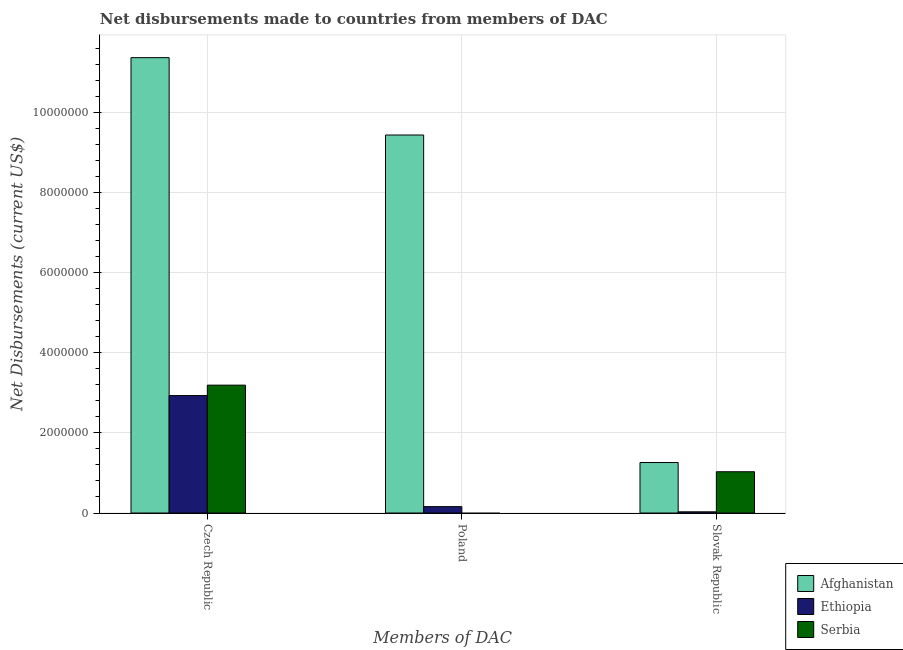How many different coloured bars are there?
Make the answer very short. 3. How many groups of bars are there?
Provide a short and direct response. 3. Are the number of bars on each tick of the X-axis equal?
Your answer should be compact. No. How many bars are there on the 3rd tick from the left?
Your response must be concise. 3. How many bars are there on the 1st tick from the right?
Provide a succinct answer. 3. What is the label of the 1st group of bars from the left?
Provide a short and direct response. Czech Republic. What is the net disbursements made by czech republic in Serbia?
Your answer should be compact. 3.19e+06. Across all countries, what is the maximum net disbursements made by poland?
Ensure brevity in your answer.  9.43e+06. Across all countries, what is the minimum net disbursements made by czech republic?
Ensure brevity in your answer.  2.93e+06. In which country was the net disbursements made by czech republic maximum?
Keep it short and to the point. Afghanistan. What is the total net disbursements made by slovak republic in the graph?
Provide a succinct answer. 2.32e+06. What is the difference between the net disbursements made by czech republic in Ethiopia and that in Afghanistan?
Give a very brief answer. -8.43e+06. What is the difference between the net disbursements made by poland in Ethiopia and the net disbursements made by czech republic in Serbia?
Offer a very short reply. -3.03e+06. What is the average net disbursements made by poland per country?
Give a very brief answer. 3.20e+06. What is the difference between the net disbursements made by poland and net disbursements made by slovak republic in Afghanistan?
Keep it short and to the point. 8.17e+06. What is the ratio of the net disbursements made by czech republic in Ethiopia to that in Afghanistan?
Your answer should be compact. 0.26. Is the difference between the net disbursements made by czech republic in Afghanistan and Ethiopia greater than the difference between the net disbursements made by poland in Afghanistan and Ethiopia?
Provide a short and direct response. No. What is the difference between the highest and the second highest net disbursements made by czech republic?
Your answer should be compact. 8.17e+06. What is the difference between the highest and the lowest net disbursements made by poland?
Your answer should be compact. 9.43e+06. In how many countries, is the net disbursements made by czech republic greater than the average net disbursements made by czech republic taken over all countries?
Your response must be concise. 1. Is it the case that in every country, the sum of the net disbursements made by czech republic and net disbursements made by poland is greater than the net disbursements made by slovak republic?
Give a very brief answer. Yes. Are all the bars in the graph horizontal?
Make the answer very short. No. How many countries are there in the graph?
Keep it short and to the point. 3. What is the difference between two consecutive major ticks on the Y-axis?
Keep it short and to the point. 2.00e+06. Does the graph contain any zero values?
Provide a short and direct response. Yes. Where does the legend appear in the graph?
Give a very brief answer. Bottom right. How many legend labels are there?
Offer a very short reply. 3. How are the legend labels stacked?
Make the answer very short. Vertical. What is the title of the graph?
Keep it short and to the point. Net disbursements made to countries from members of DAC. Does "French Polynesia" appear as one of the legend labels in the graph?
Give a very brief answer. No. What is the label or title of the X-axis?
Your answer should be compact. Members of DAC. What is the label or title of the Y-axis?
Provide a succinct answer. Net Disbursements (current US$). What is the Net Disbursements (current US$) of Afghanistan in Czech Republic?
Offer a terse response. 1.14e+07. What is the Net Disbursements (current US$) of Ethiopia in Czech Republic?
Keep it short and to the point. 2.93e+06. What is the Net Disbursements (current US$) of Serbia in Czech Republic?
Provide a short and direct response. 3.19e+06. What is the Net Disbursements (current US$) of Afghanistan in Poland?
Ensure brevity in your answer.  9.43e+06. What is the Net Disbursements (current US$) in Serbia in Poland?
Your answer should be very brief. 0. What is the Net Disbursements (current US$) in Afghanistan in Slovak Republic?
Your answer should be compact. 1.26e+06. What is the Net Disbursements (current US$) in Serbia in Slovak Republic?
Offer a very short reply. 1.03e+06. Across all Members of DAC, what is the maximum Net Disbursements (current US$) in Afghanistan?
Keep it short and to the point. 1.14e+07. Across all Members of DAC, what is the maximum Net Disbursements (current US$) in Ethiopia?
Provide a succinct answer. 2.93e+06. Across all Members of DAC, what is the maximum Net Disbursements (current US$) of Serbia?
Ensure brevity in your answer.  3.19e+06. Across all Members of DAC, what is the minimum Net Disbursements (current US$) of Afghanistan?
Provide a succinct answer. 1.26e+06. What is the total Net Disbursements (current US$) of Afghanistan in the graph?
Offer a very short reply. 2.20e+07. What is the total Net Disbursements (current US$) of Ethiopia in the graph?
Ensure brevity in your answer.  3.12e+06. What is the total Net Disbursements (current US$) in Serbia in the graph?
Provide a short and direct response. 4.22e+06. What is the difference between the Net Disbursements (current US$) in Afghanistan in Czech Republic and that in Poland?
Provide a short and direct response. 1.93e+06. What is the difference between the Net Disbursements (current US$) in Ethiopia in Czech Republic and that in Poland?
Give a very brief answer. 2.77e+06. What is the difference between the Net Disbursements (current US$) in Afghanistan in Czech Republic and that in Slovak Republic?
Offer a very short reply. 1.01e+07. What is the difference between the Net Disbursements (current US$) in Ethiopia in Czech Republic and that in Slovak Republic?
Your answer should be very brief. 2.90e+06. What is the difference between the Net Disbursements (current US$) in Serbia in Czech Republic and that in Slovak Republic?
Keep it short and to the point. 2.16e+06. What is the difference between the Net Disbursements (current US$) in Afghanistan in Poland and that in Slovak Republic?
Keep it short and to the point. 8.17e+06. What is the difference between the Net Disbursements (current US$) in Ethiopia in Poland and that in Slovak Republic?
Offer a very short reply. 1.30e+05. What is the difference between the Net Disbursements (current US$) in Afghanistan in Czech Republic and the Net Disbursements (current US$) in Ethiopia in Poland?
Give a very brief answer. 1.12e+07. What is the difference between the Net Disbursements (current US$) in Afghanistan in Czech Republic and the Net Disbursements (current US$) in Ethiopia in Slovak Republic?
Provide a succinct answer. 1.13e+07. What is the difference between the Net Disbursements (current US$) of Afghanistan in Czech Republic and the Net Disbursements (current US$) of Serbia in Slovak Republic?
Your answer should be compact. 1.03e+07. What is the difference between the Net Disbursements (current US$) of Ethiopia in Czech Republic and the Net Disbursements (current US$) of Serbia in Slovak Republic?
Give a very brief answer. 1.90e+06. What is the difference between the Net Disbursements (current US$) in Afghanistan in Poland and the Net Disbursements (current US$) in Ethiopia in Slovak Republic?
Your response must be concise. 9.40e+06. What is the difference between the Net Disbursements (current US$) in Afghanistan in Poland and the Net Disbursements (current US$) in Serbia in Slovak Republic?
Give a very brief answer. 8.40e+06. What is the difference between the Net Disbursements (current US$) of Ethiopia in Poland and the Net Disbursements (current US$) of Serbia in Slovak Republic?
Your response must be concise. -8.70e+05. What is the average Net Disbursements (current US$) in Afghanistan per Members of DAC?
Offer a terse response. 7.35e+06. What is the average Net Disbursements (current US$) of Ethiopia per Members of DAC?
Your answer should be compact. 1.04e+06. What is the average Net Disbursements (current US$) in Serbia per Members of DAC?
Provide a succinct answer. 1.41e+06. What is the difference between the Net Disbursements (current US$) of Afghanistan and Net Disbursements (current US$) of Ethiopia in Czech Republic?
Provide a short and direct response. 8.43e+06. What is the difference between the Net Disbursements (current US$) in Afghanistan and Net Disbursements (current US$) in Serbia in Czech Republic?
Your answer should be very brief. 8.17e+06. What is the difference between the Net Disbursements (current US$) of Afghanistan and Net Disbursements (current US$) of Ethiopia in Poland?
Ensure brevity in your answer.  9.27e+06. What is the difference between the Net Disbursements (current US$) of Afghanistan and Net Disbursements (current US$) of Ethiopia in Slovak Republic?
Make the answer very short. 1.23e+06. What is the difference between the Net Disbursements (current US$) in Ethiopia and Net Disbursements (current US$) in Serbia in Slovak Republic?
Your answer should be very brief. -1.00e+06. What is the ratio of the Net Disbursements (current US$) in Afghanistan in Czech Republic to that in Poland?
Offer a very short reply. 1.2. What is the ratio of the Net Disbursements (current US$) in Ethiopia in Czech Republic to that in Poland?
Provide a succinct answer. 18.31. What is the ratio of the Net Disbursements (current US$) in Afghanistan in Czech Republic to that in Slovak Republic?
Provide a short and direct response. 9.02. What is the ratio of the Net Disbursements (current US$) in Ethiopia in Czech Republic to that in Slovak Republic?
Make the answer very short. 97.67. What is the ratio of the Net Disbursements (current US$) of Serbia in Czech Republic to that in Slovak Republic?
Keep it short and to the point. 3.1. What is the ratio of the Net Disbursements (current US$) in Afghanistan in Poland to that in Slovak Republic?
Keep it short and to the point. 7.48. What is the ratio of the Net Disbursements (current US$) of Ethiopia in Poland to that in Slovak Republic?
Your answer should be compact. 5.33. What is the difference between the highest and the second highest Net Disbursements (current US$) in Afghanistan?
Your answer should be very brief. 1.93e+06. What is the difference between the highest and the second highest Net Disbursements (current US$) of Ethiopia?
Make the answer very short. 2.77e+06. What is the difference between the highest and the lowest Net Disbursements (current US$) in Afghanistan?
Your response must be concise. 1.01e+07. What is the difference between the highest and the lowest Net Disbursements (current US$) in Ethiopia?
Your response must be concise. 2.90e+06. What is the difference between the highest and the lowest Net Disbursements (current US$) of Serbia?
Give a very brief answer. 3.19e+06. 